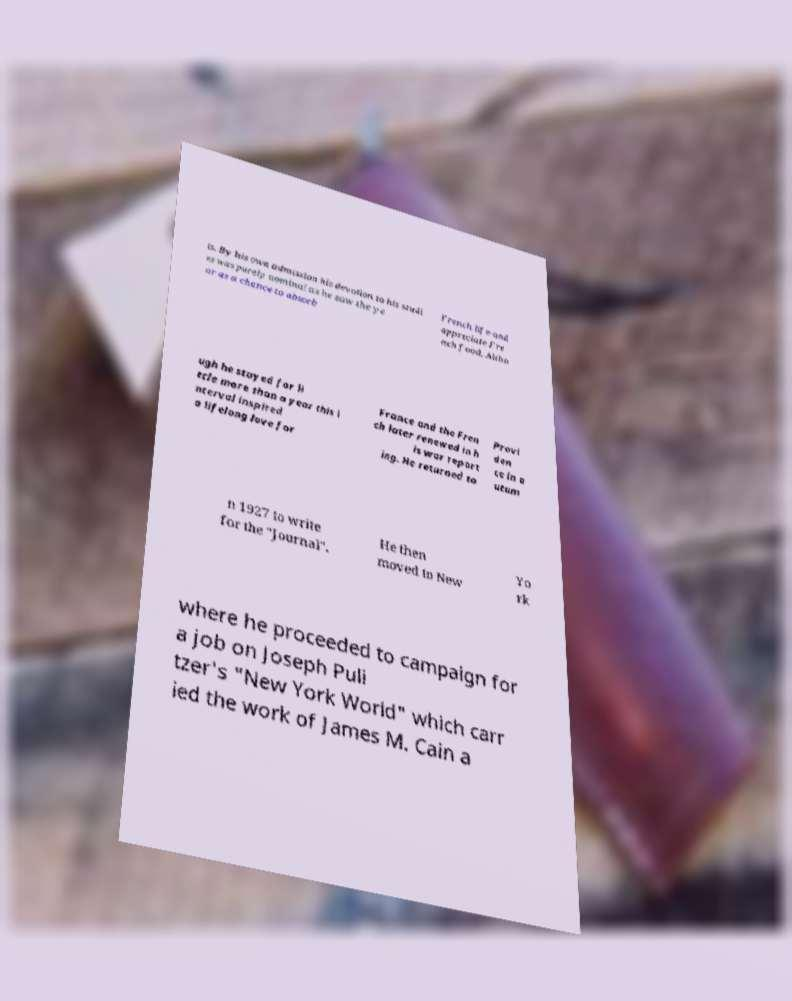Please identify and transcribe the text found in this image. is. By his own admission his devotion to his studi es was purely nominal as he saw the ye ar as a chance to absorb French life and appreciate Fre nch food. Altho ugh he stayed for li ttle more than a year this i nterval inspired a lifelong love for France and the Fren ch later renewed in h is war report ing. He returned to Provi den ce in a utum n 1927 to write for the "Journal". He then moved to New Yo rk where he proceeded to campaign for a job on Joseph Puli tzer's "New York World" which carr ied the work of James M. Cain a 